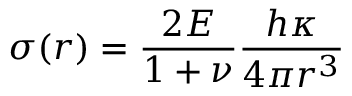<formula> <loc_0><loc_0><loc_500><loc_500>\sigma ( r ) = \frac { 2 E } { 1 + \nu } \frac { h \kappa } { 4 \pi r ^ { 3 } }</formula> 